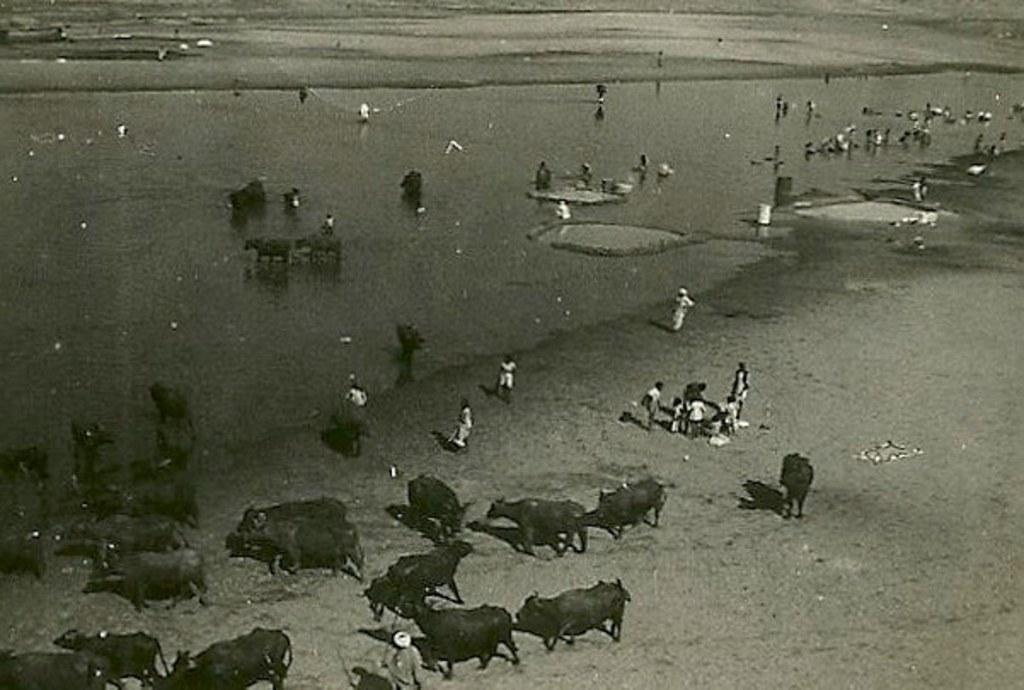What types of living beings are present in the image? There are animals and people in the image. Can you describe the color scheme of the image? The image is black and white in color. How many sisters are present in the image? There is no mention of sisters in the image, as it only states that there are people and animals present. 